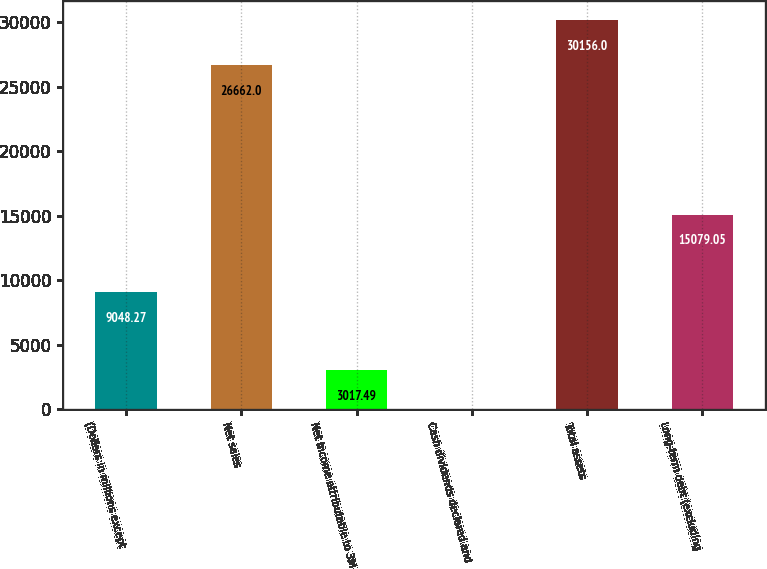<chart> <loc_0><loc_0><loc_500><loc_500><bar_chart><fcel>(Dollars in millions except<fcel>Net sales<fcel>Net income attributable to 3M<fcel>Cash dividends declared and<fcel>Total assets<fcel>Long-term debt (excluding<nl><fcel>9048.27<fcel>26662<fcel>3017.49<fcel>2.1<fcel>30156<fcel>15079<nl></chart> 